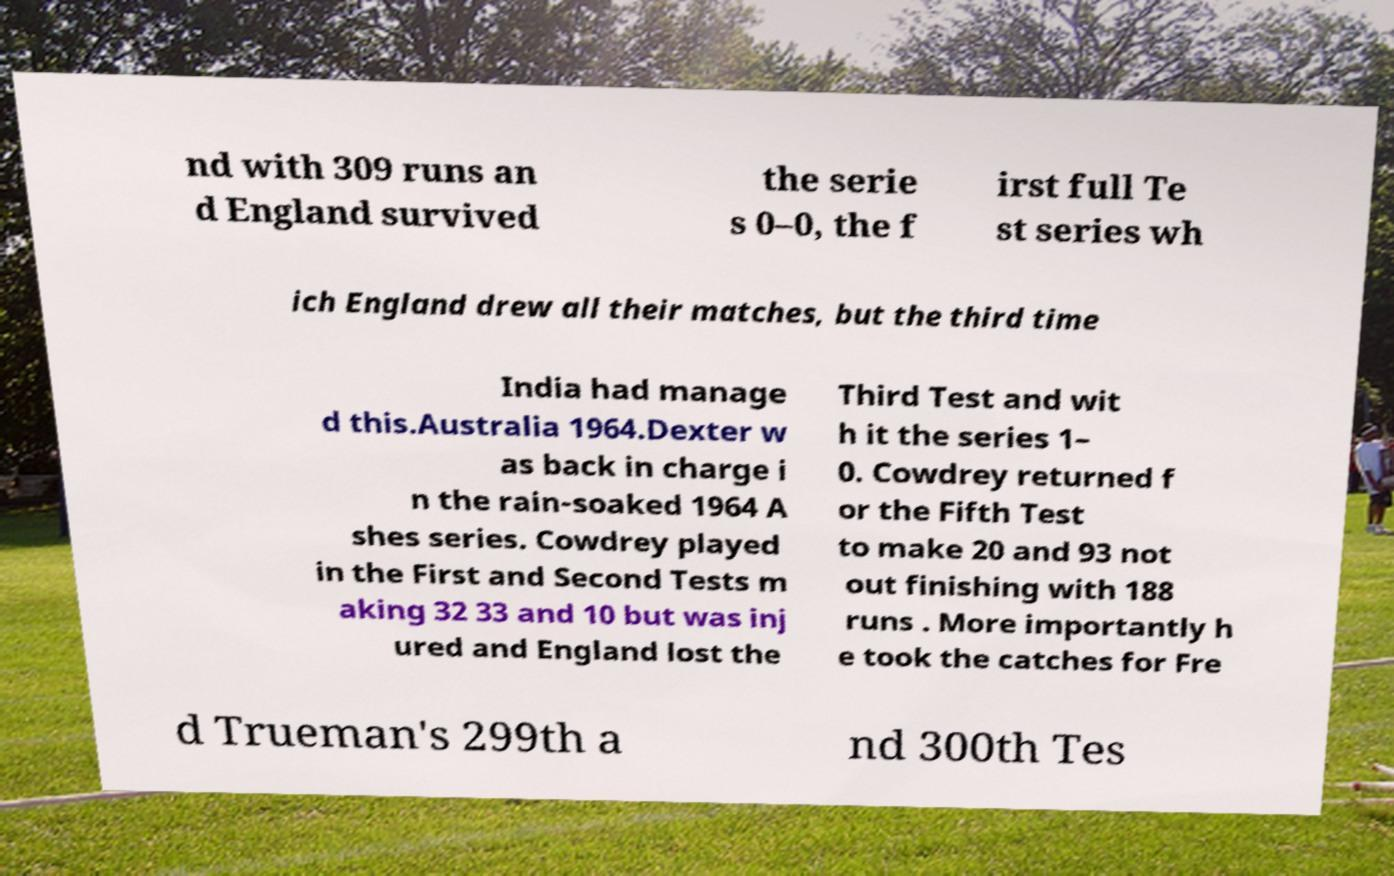Could you extract and type out the text from this image? nd with 309 runs an d England survived the serie s 0–0, the f irst full Te st series wh ich England drew all their matches, but the third time India had manage d this.Australia 1964.Dexter w as back in charge i n the rain-soaked 1964 A shes series. Cowdrey played in the First and Second Tests m aking 32 33 and 10 but was inj ured and England lost the Third Test and wit h it the series 1– 0. Cowdrey returned f or the Fifth Test to make 20 and 93 not out finishing with 188 runs . More importantly h e took the catches for Fre d Trueman's 299th a nd 300th Tes 